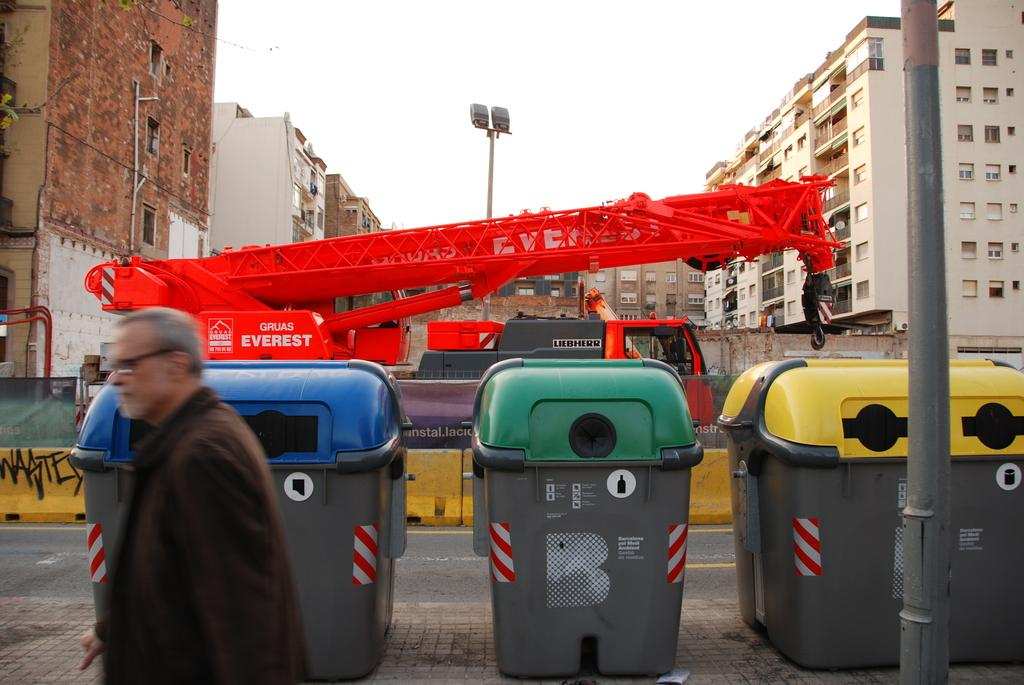<image>
Present a compact description of the photo's key features. A man walks in front of a orange crane labelled Gruas Everest. 